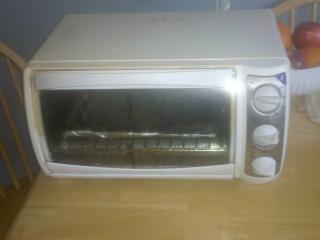Is the toaster on?
Keep it brief. No. What are the two labeled items to the right of the appliance?
Write a very short answer. Apple and orange. What is on top of the toaster oven?
Give a very brief answer. Nothing. Is the oven on?
Write a very short answer. No. What is sitting next to toaster oven?
Be succinct. Fruit. What is the appliance sitting on?
Write a very short answer. Table. What color is the oven?
Give a very brief answer. White. What is this appliance?
Write a very short answer. Toaster oven. Is the oven light turned on?
Quick response, please. No. What is stuffed inside the toaster oven?
Keep it brief. Aluminum foil. What is in the microwave?
Be succinct. Nothing. How many racks in oven?
Short answer required. 1. What is the item in the middle of the image used for?
Write a very short answer. Cooking. Is this a toaster?
Write a very short answer. Yes. What brand is the toaster oven?
Quick response, please. Unknown. 